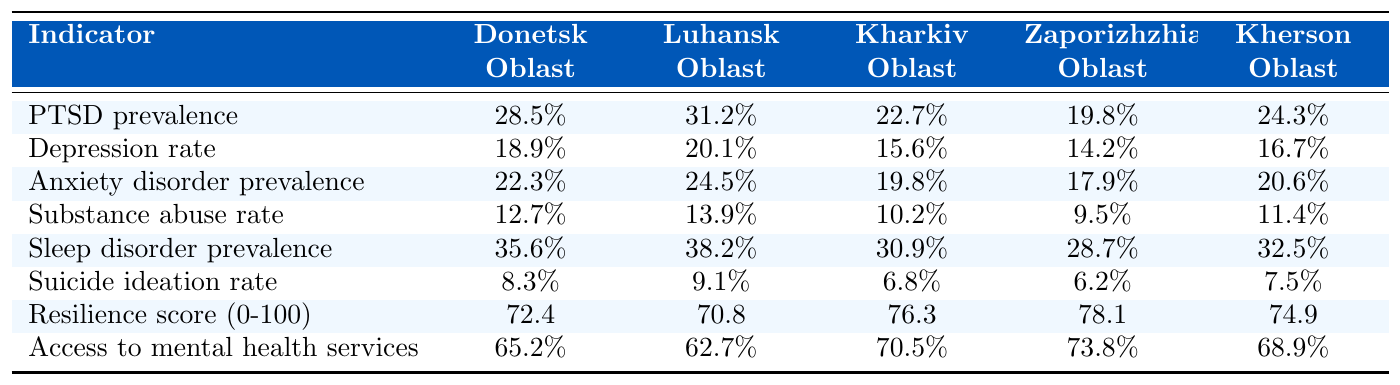What is the PTSD prevalence in Luhansk Oblast? The table shows that the PTSD prevalence in Luhansk Oblast is 31.2%.
Answer: 31.2% Which region has the highest sleep disorder prevalence? By comparing the values for sleep disorder prevalence, Donetsk Oblast has the highest at 35.6%.
Answer: Donetsk Oblast What is the average depression rate among these regions? To find the average, add the depression rates (18.9 + 20.1 + 15.6 + 14.2 + 16.7 = 85.5) and divide by 5, resulting in 85.5 / 5 = 17.1%.
Answer: 17.1% Which region has lower substance abuse rates: Kharkiv Oblast or Zaporizhzhia Oblast? Kharkiv Oblast has a 10.2% substance abuse rate while Zaporizhzhia Oblast has 9.5%, indicating that Zaporizhzhia has lower rates.
Answer: Zaporizhzhia Oblast What is the resilience score for Kharkiv Oblast? The table indicates that Kharkiv Oblast has a resilience score of 76.3.
Answer: 76.3 Which region has both the highest PTSD prevalence and the highest sleep disorder prevalence? The highest PTSD prevalence is in Luhansk Oblast (31.2%), and the highest sleep disorder prevalence is in Donetsk Oblast (35.6%). There are no overlaps between the highest in both indicators.
Answer: None Is the suicide ideation rate in Kharkiv Oblast higher than in Zaporizhzhia Oblast? The suicide ideation rate in Kharkiv Oblast is 6.8% while in Zaporizhzhia Oblast it is 6.2%, confirming that Kharkiv's rate is higher.
Answer: Yes What is the difference in resilience scores between Donetsk Oblast and Zaporizhzhia Oblast? Resilience score for Donetsk Oblast is 72.4 and for Zaporizhzhia Oblast is 78.1. The difference is 78.1 - 72.4 = 5.7.
Answer: 5.7 How much higher is the access to mental health services in Kharkiv Oblast compared to Luhansk Oblast? Kharkiv Oblast has a 70.5% access rate, and Luhansk Oblast has 62.7%. The difference is 70.5 - 62.7 = 7.8%.
Answer: 7.8% Which indicators show a higher prevalence in Luhansk Oblast compared to the other regions? Luhansk Oblast has higher values for PTSD prevalence (31.2%) and anxiety disorder prevalence (24.5%) compared to the other regions, indicating higher prevalence in these categories.
Answer: PTSD and anxiety disorder prevalence 